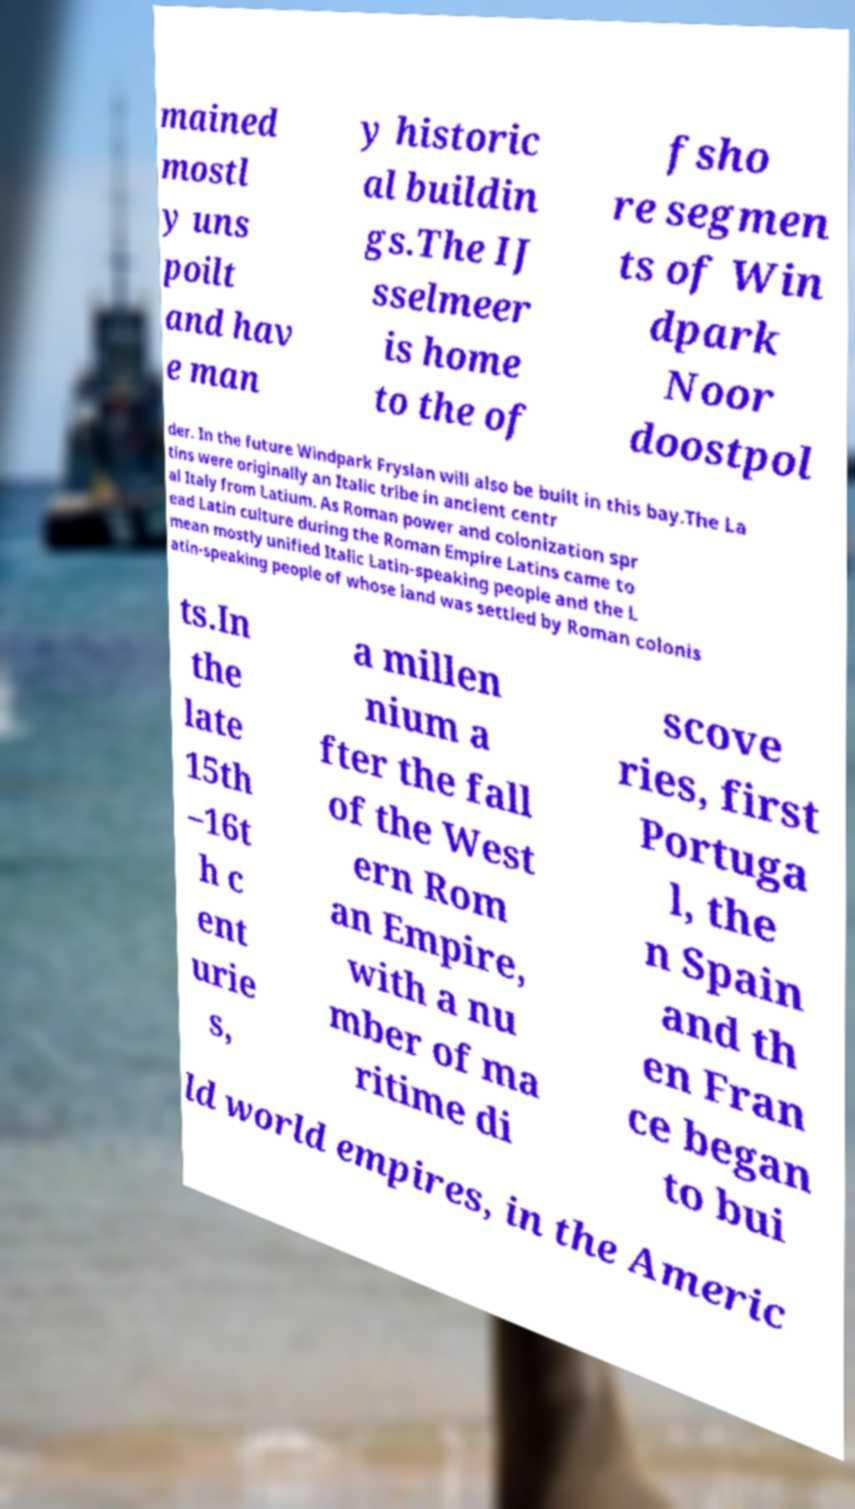There's text embedded in this image that I need extracted. Can you transcribe it verbatim? mained mostl y uns poilt and hav e man y historic al buildin gs.The IJ sselmeer is home to the of fsho re segmen ts of Win dpark Noor doostpol der. In the future Windpark Fryslan will also be built in this bay.The La tins were originally an Italic tribe in ancient centr al Italy from Latium. As Roman power and colonization spr ead Latin culture during the Roman Empire Latins came to mean mostly unified Italic Latin-speaking people and the L atin-speaking people of whose land was settled by Roman colonis ts.In the late 15th –16t h c ent urie s, a millen nium a fter the fall of the West ern Rom an Empire, with a nu mber of ma ritime di scove ries, first Portuga l, the n Spain and th en Fran ce began to bui ld world empires, in the Americ 